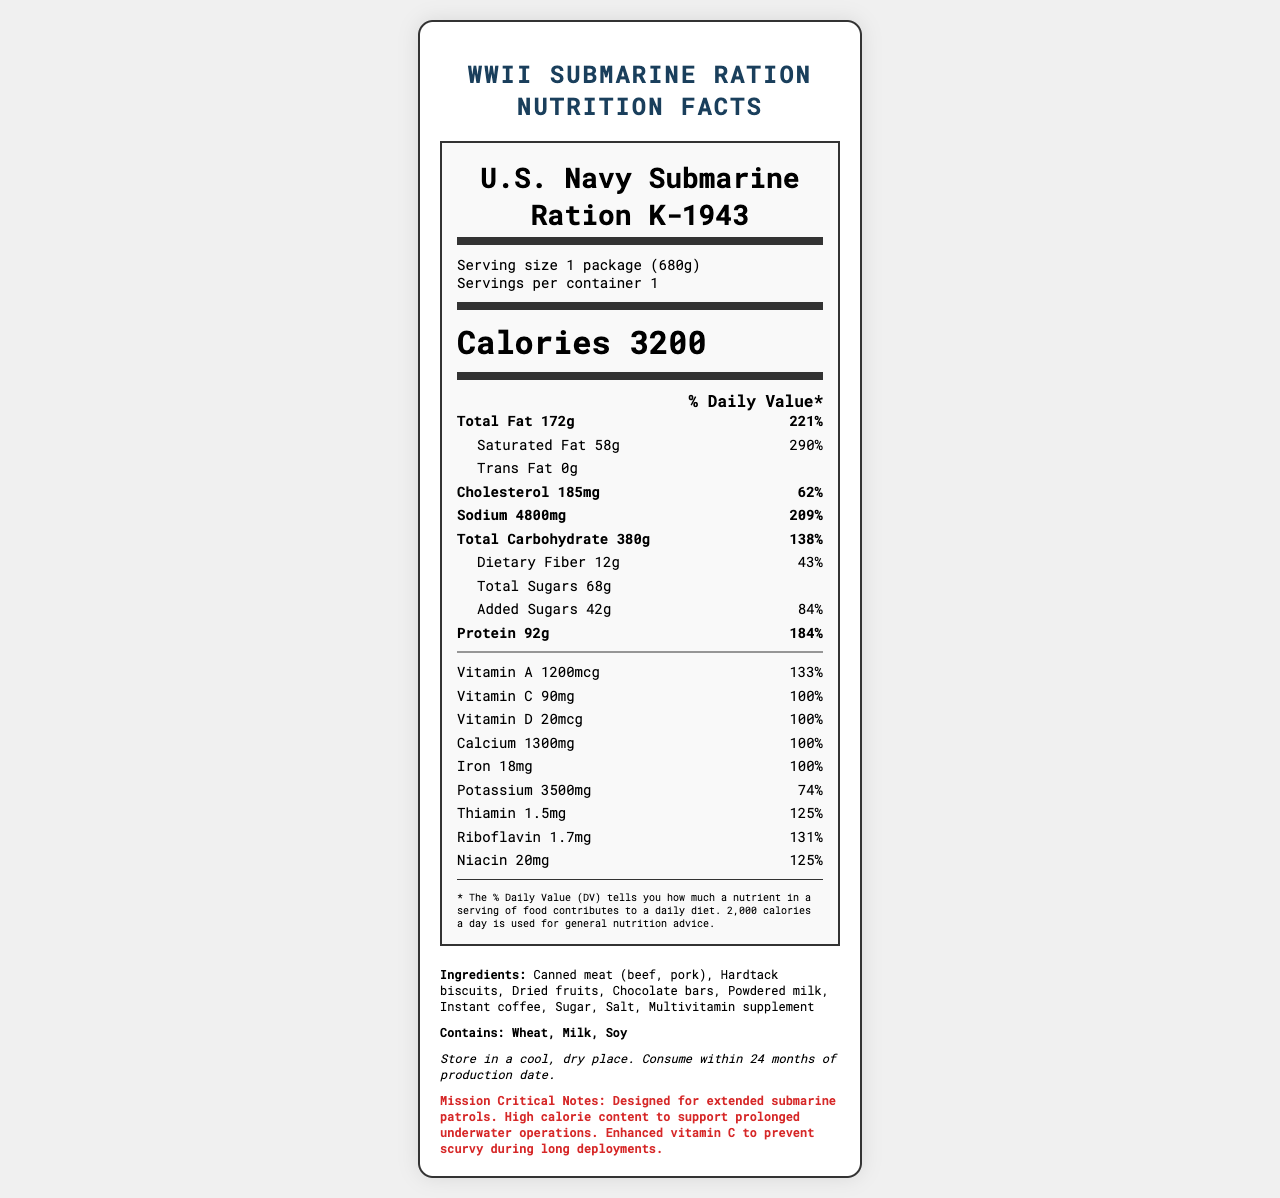what is the serving size of the U.S. Navy Submarine Ration K-1943? The serving size is mentioned in the serving information section of the document.
Answer: 1 package (680g) How many calories are in one serving of the U.S. Navy Submarine Ration K-1943? The calories per serving are highlighted in a bold font in the middle of the document.
Answer: 3200 What is the total amount of protein in one package? The total amount of protein is listed in the main nutrients section under the protein category.
Answer: 92g What is the daily value percentage of sodium in one serving? The percentage daily value of sodium is shown next to its amount in the nutrient rows.
Answer: 209% How much added sugar is present in one serving? The amount of added sugar is listed under the sub-nutrients section.
Answer: 42g Which of the following ingredients is included in the U.S. Navy Submarine Ration K-1943? A. Fresh vegetables B. Chocolate bars C. Fresh fruit D. Canned fish The ingredient "Chocolate bars" is listed under the ingredients section, whereas fresh vegetables, fresh fruit, and canned fish are not.
Answer: B What is the percentage daily value of vitamin C? A. 90% B. 95% C. 100% D. 105% The document states that the daily value percentage of vitamin C is 100%.
Answer: C Is the U.S. Navy Submarine Ration K-1943 gluten-free? The allergens section lists "Wheat" as an allergen, indicating that the ration is not gluten-free.
Answer: No How are these rations stored to ensure their longevity? The storage instructions are explicitly provided in the storage section of the document.
Answer: Store in a cool, dry place. Consume within 24 months of production date. What is the main purpose of the high vitamin C content in these rations? The mission-critical notes state that the enhanced vitamin C is to prevent scurvy.
Answer: To prevent scurvy during long deployments. Identify three main nutrients in this ration that contribute significantly to the daily recommended values. Provide their daily value percentages. These nutrients have high daily value percentages and are listed as main nutrients.
Answer: Total Fat (221%), Protein (184%), and Total Carbohydrate (138%) What is the main idea and purpose of this document? The document's content and layout focus on conveying the nutritional details and special considerations for this specific wartime ration.
Answer: The document provides detailed nutritional information about the U.S. Navy Submarine Ration K-1943, including serving size, calorie content, macronutrients, vitamins, minerals, and storage instructions. It also highlights the purpose of the ration's high calorie and nutrient content to support long submarine patrols and prevent deficiencies such as scurvy. What is the exact amount of thiamin and its daily value percentage? The amount of thiamin is listed under the nutrient rows along with its daily value percentage.
Answer: 1.5mg, 125% How many servings are there per container? The serving information specifies that there is one serving per container.
Answer: 1 What are the cholesterol and sodium amounts in one serving? The amounts are clearly listed under the main nutrients section, each with a separate row for cholesterol and sodium.
Answer: Cholesterol: 185mg, Sodium: 4800mg What year were these submarine rations produced? The document does not provide information on the specific year of production for these rations.
Answer: Cannot be determined 